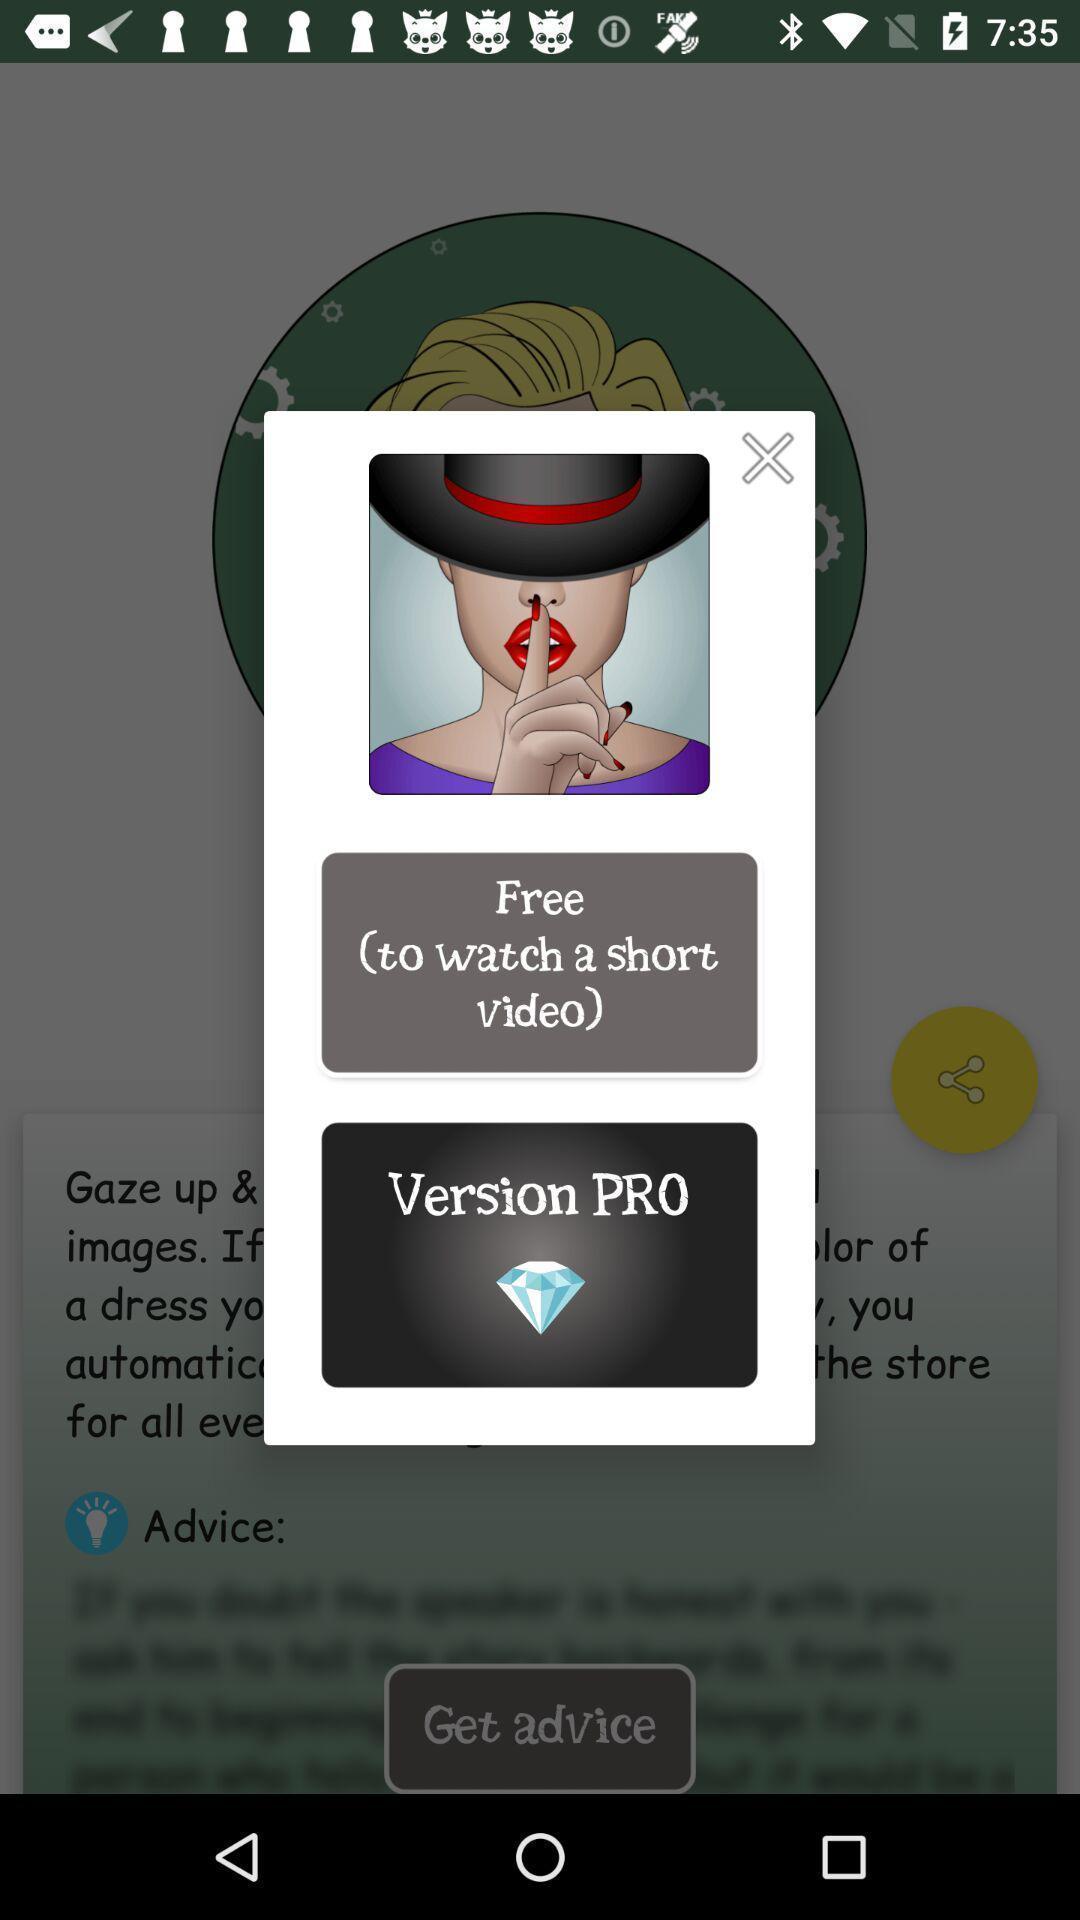Explain what's happening in this screen capture. Pop-up showing information about watching videos. 